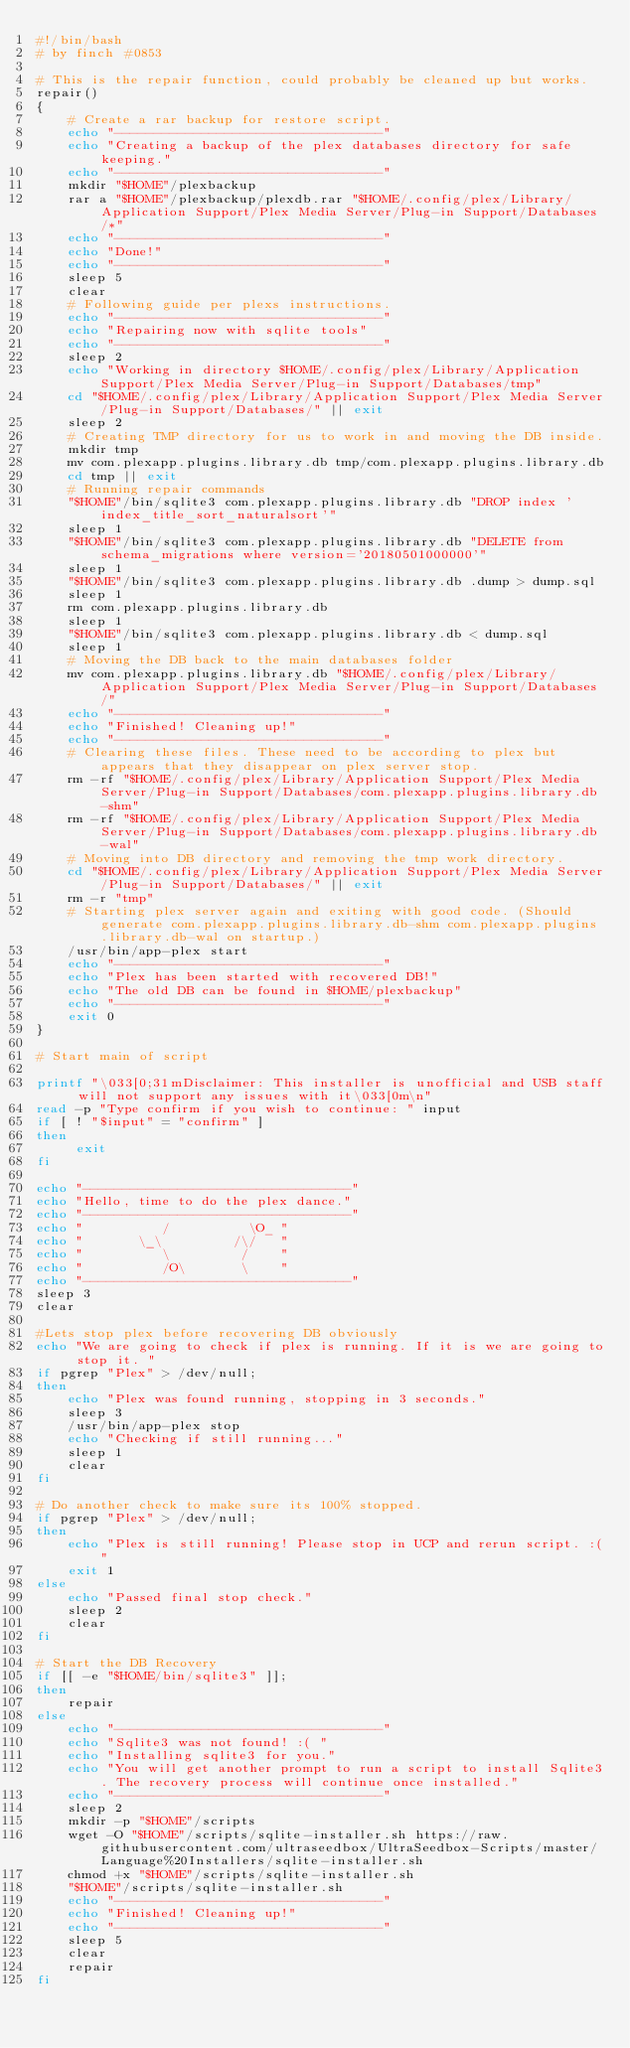<code> <loc_0><loc_0><loc_500><loc_500><_Bash_>#!/bin/bash
# by finch #0853

# This is the repair function, could probably be cleaned up but works. 
repair()
{
    # Create a rar backup for restore script.
    echo "----------------------------------"
    echo "Creating a backup of the plex databases directory for safe keeping."
    echo "----------------------------------"
    mkdir "$HOME"/plexbackup
    rar a "$HOME"/plexbackup/plexdb.rar "$HOME/.config/plex/Library/Application Support/Plex Media Server/Plug-in Support/Databases/*"
    echo "----------------------------------"
    echo "Done!"
    echo "----------------------------------"
    sleep 5
    clear
    # Following guide per plexs instructions.
    echo "----------------------------------"
    echo "Repairing now with sqlite tools"
    echo "----------------------------------"
    sleep 2
    echo "Working in directory $HOME/.config/plex/Library/Application Support/Plex Media Server/Plug-in Support/Databases/tmp"
    cd "$HOME/.config/plex/Library/Application Support/Plex Media Server/Plug-in Support/Databases/" || exit
    sleep 2
    # Creating TMP directory for us to work in and moving the DB inside.
    mkdir tmp
    mv com.plexapp.plugins.library.db tmp/com.plexapp.plugins.library.db
    cd tmp || exit
    # Running repair commands
    "$HOME"/bin/sqlite3 com.plexapp.plugins.library.db "DROP index 'index_title_sort_naturalsort'"
    sleep 1
    "$HOME"/bin/sqlite3 com.plexapp.plugins.library.db "DELETE from schema_migrations where version='20180501000000'"
    sleep 1
    "$HOME"/bin/sqlite3 com.plexapp.plugins.library.db .dump > dump.sql
    sleep 1
    rm com.plexapp.plugins.library.db
    sleep 1
    "$HOME"/bin/sqlite3 com.plexapp.plugins.library.db < dump.sql
    sleep 1
    # Moving the DB back to the main databases folder
    mv com.plexapp.plugins.library.db "$HOME/.config/plex/Library/Application Support/Plex Media Server/Plug-in Support/Databases/"
    echo "----------------------------------"
    echo "Finished! Cleaning up!"
    echo "----------------------------------"
    # Clearing these files. These need to be according to plex but appears that they disappear on plex server stop. 
    rm -rf "$HOME/.config/plex/Library/Application Support/Plex Media Server/Plug-in Support/Databases/com.plexapp.plugins.library.db-shm"
    rm -rf "$HOME/.config/plex/Library/Application Support/Plex Media Server/Plug-in Support/Databases/com.plexapp.plugins.library.db-wal"
    # Moving into DB directory and removing the tmp work directory. 
    cd "$HOME/.config/plex/Library/Application Support/Plex Media Server/Plug-in Support/Databases/" || exit
    rm -r "tmp"
    # Starting plex server again and exiting with good code. (Should generate com.plexapp.plugins.library.db-shm com.plexapp.plugins.library.db-wal on startup.)
    /usr/bin/app-plex start
    echo "----------------------------------"
    echo "Plex has been started with recovered DB!"
    echo "The old DB can be found in $HOME/plexbackup"
    echo "----------------------------------"
    exit 0
}

# Start main of script

printf "\033[0;31mDisclaimer: This installer is unofficial and USB staff will not support any issues with it\033[0m\n"
read -p "Type confirm if you wish to continue: " input
if [ ! "$input" = "confirm" ]
then
     exit
fi

echo "----------------------------------"
echo "Hello, time to do the plex dance."
echo "----------------------------------"
echo "          /          \O_ "
echo "       \_\         /\/   "
echo "          \         /    "
echo "          /O\       \    "
echo "----------------------------------"
sleep 3
clear

#Lets stop plex before recovering DB obviously
echo "We are going to check if plex is running. If it is we are going to stop it. "
if pgrep "Plex" > /dev/null;
then
    echo "Plex was found running, stopping in 3 seconds."
    sleep 3
    /usr/bin/app-plex stop
    echo "Checking if still running..."
    sleep 1
    clear
fi

# Do another check to make sure its 100% stopped.
if pgrep "Plex" > /dev/null;
then
    echo "Plex is still running! Please stop in UCP and rerun script. :("
    exit 1
else 
    echo "Passed final stop check."
    sleep 2
    clear
fi

# Start the DB Recovery
if [[ -e "$HOME/bin/sqlite3" ]]; 
then
    repair
else
    echo "----------------------------------"
    echo "Sqlite3 was not found! :( "
    echo "Installing sqlite3 for you."
    echo "You will get another prompt to run a script to install Sqlite3. The recovery process will continue once installed."
    echo "----------------------------------"
    sleep 2
    mkdir -p "$HOME"/scripts
    wget -O "$HOME"/scripts/sqlite-installer.sh https://raw.githubusercontent.com/ultraseedbox/UltraSeedbox-Scripts/master/Language%20Installers/sqlite-installer.sh
    chmod +x "$HOME"/scripts/sqlite-installer.sh
    "$HOME"/scripts/sqlite-installer.sh
    echo "----------------------------------"
    echo "Finished! Cleaning up!"
    echo "----------------------------------"
    sleep 5
    clear
    repair
fi
</code> 